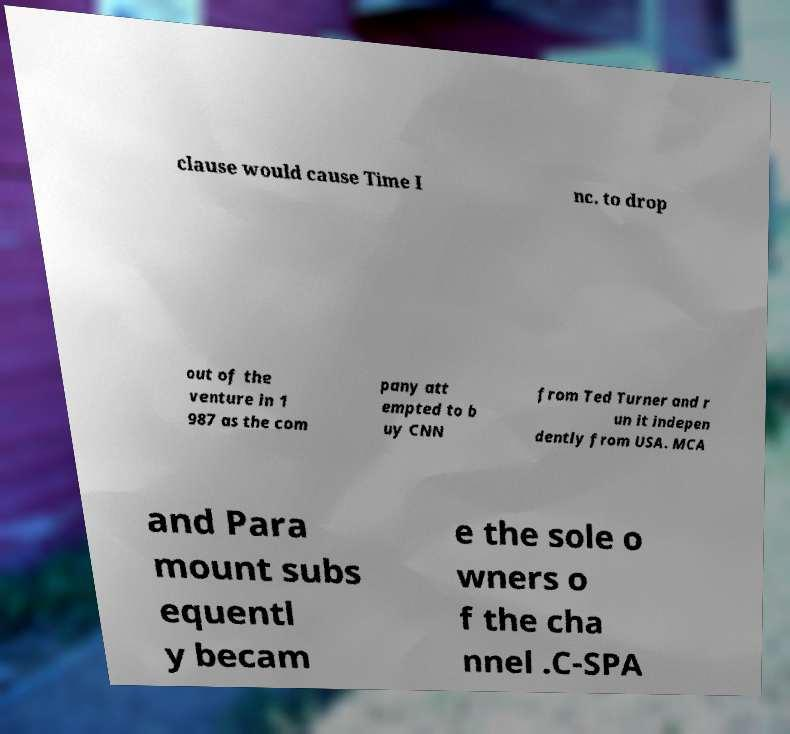For documentation purposes, I need the text within this image transcribed. Could you provide that? clause would cause Time I nc. to drop out of the venture in 1 987 as the com pany att empted to b uy CNN from Ted Turner and r un it indepen dently from USA. MCA and Para mount subs equentl y becam e the sole o wners o f the cha nnel .C-SPA 